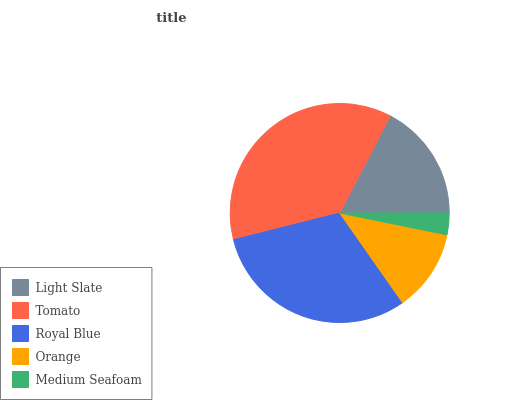Is Medium Seafoam the minimum?
Answer yes or no. Yes. Is Tomato the maximum?
Answer yes or no. Yes. Is Royal Blue the minimum?
Answer yes or no. No. Is Royal Blue the maximum?
Answer yes or no. No. Is Tomato greater than Royal Blue?
Answer yes or no. Yes. Is Royal Blue less than Tomato?
Answer yes or no. Yes. Is Royal Blue greater than Tomato?
Answer yes or no. No. Is Tomato less than Royal Blue?
Answer yes or no. No. Is Light Slate the high median?
Answer yes or no. Yes. Is Light Slate the low median?
Answer yes or no. Yes. Is Royal Blue the high median?
Answer yes or no. No. Is Tomato the low median?
Answer yes or no. No. 